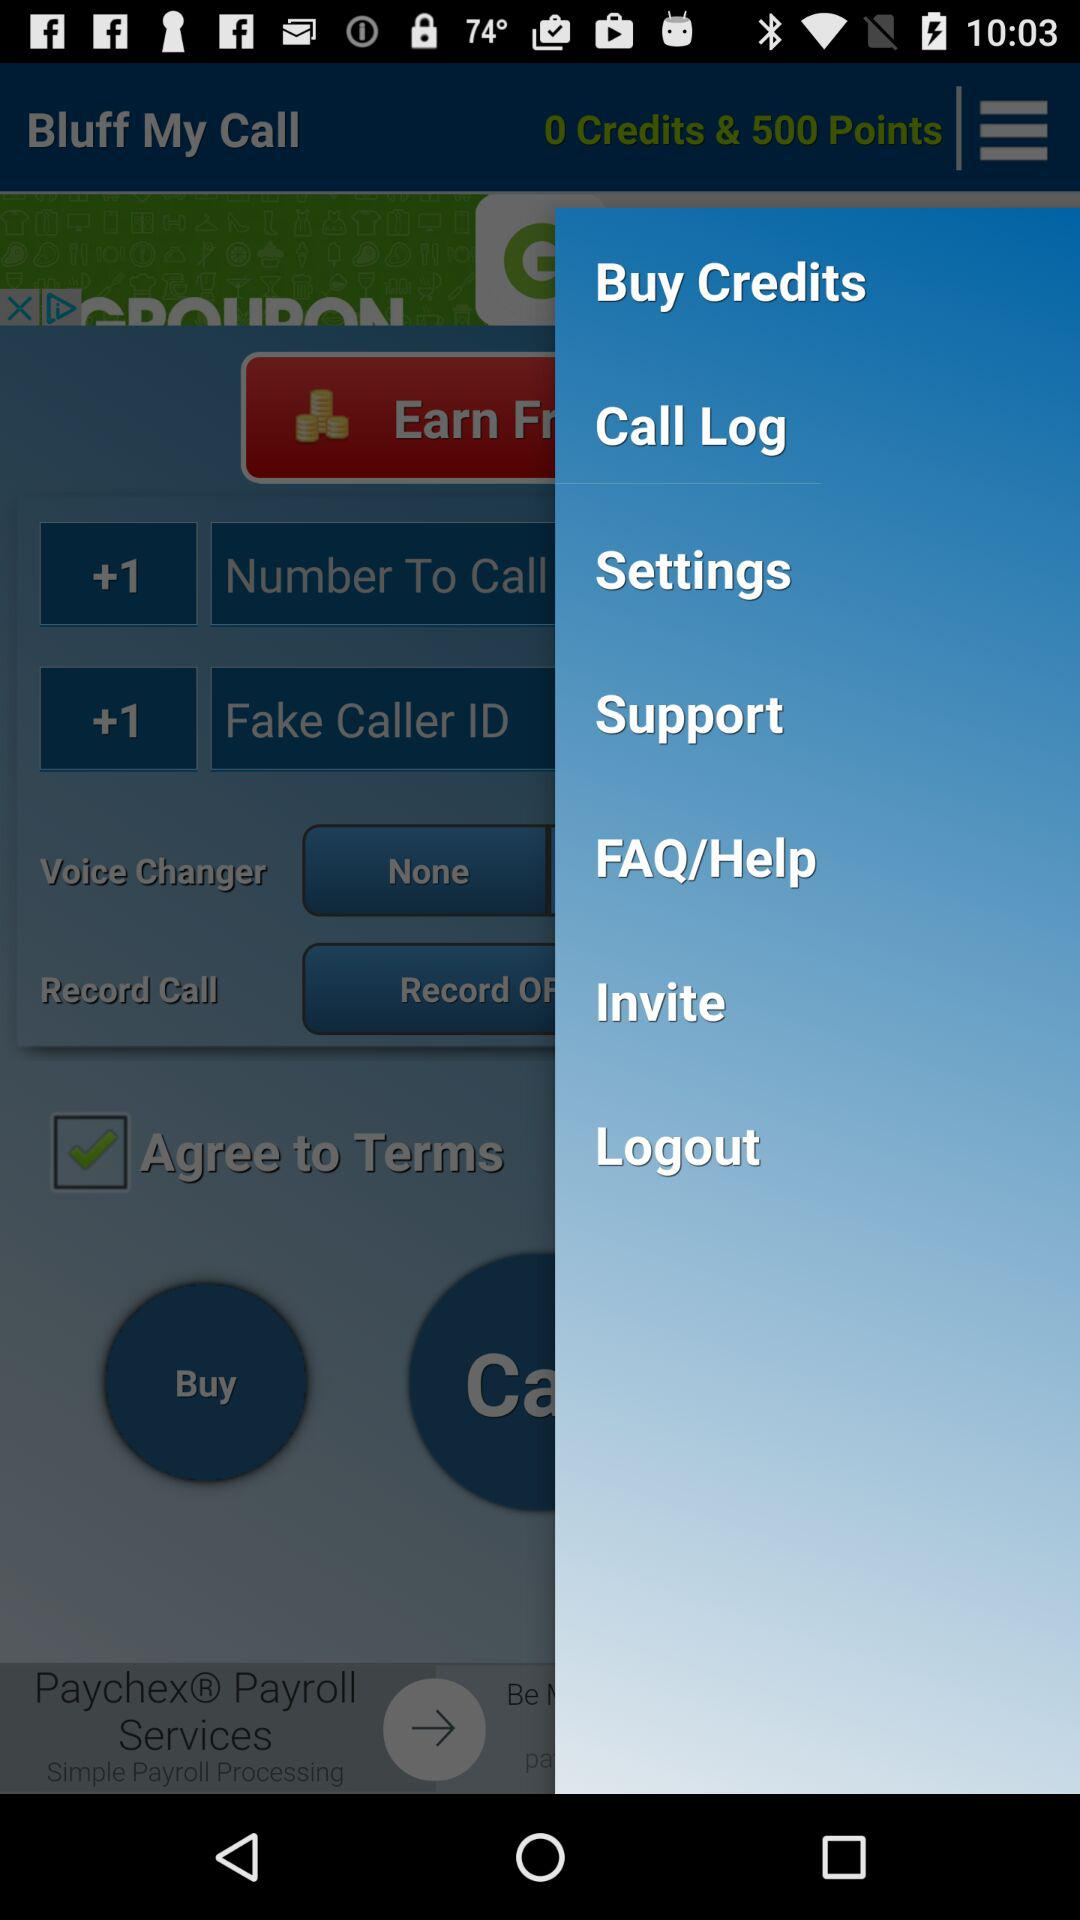How many credits are shown on the screen? There are 0 credits shown on the screen. 